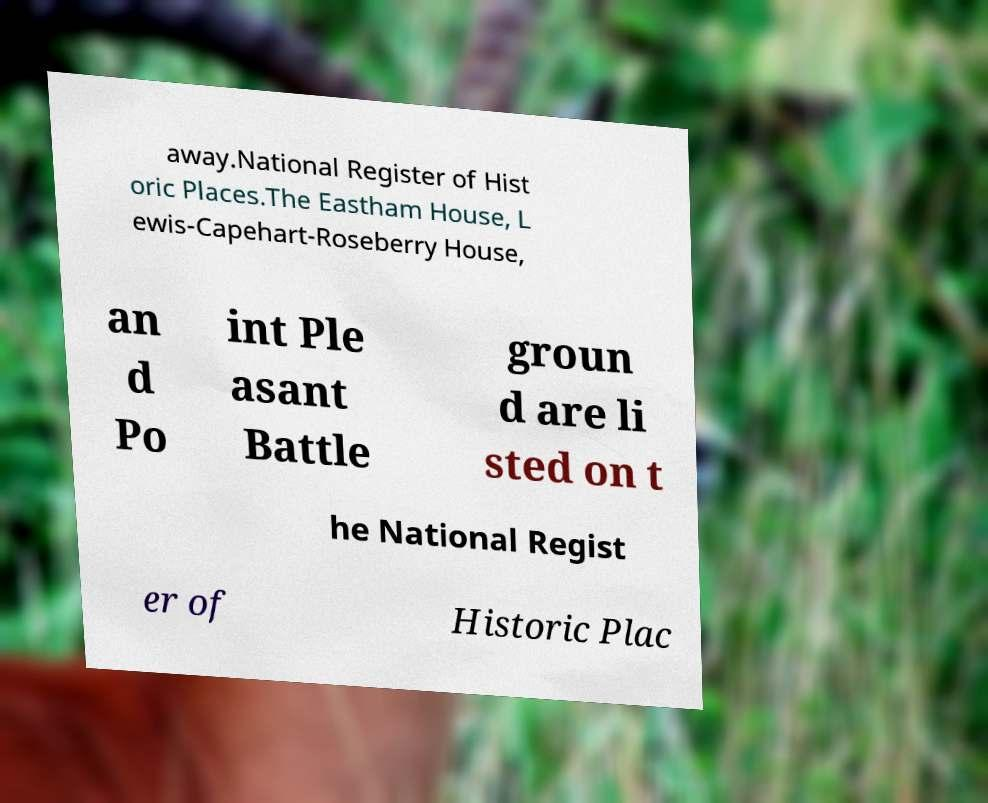I need the written content from this picture converted into text. Can you do that? away.National Register of Hist oric Places.The Eastham House, L ewis-Capehart-Roseberry House, an d Po int Ple asant Battle groun d are li sted on t he National Regist er of Historic Plac 